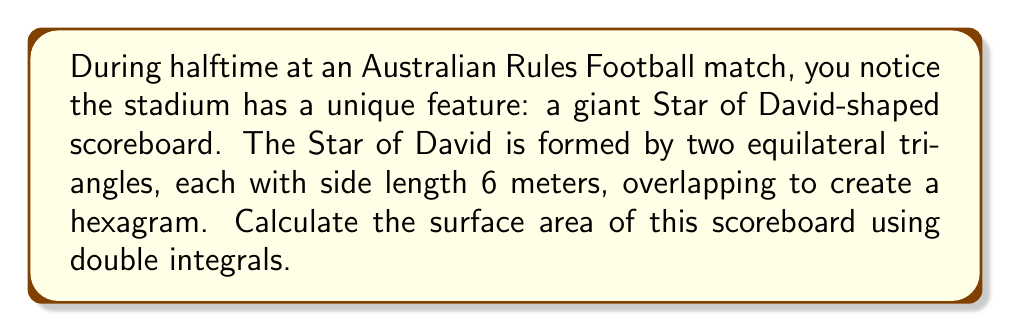Give your solution to this math problem. Let's approach this step-by-step:

1) First, we need to set up our coordinate system. Let's place the center of the Star of David at the origin (0,0) and align one of the triangles so that its base is parallel to the x-axis.

2) The Star of David can be divided into 12 congruent right triangles. We'll focus on one of these triangles in the first quadrant.

3) The equations of the lines forming this triangle are:
   $$y = \frac{\sqrt{3}}{3}x$$ (lower line)
   $$y = \sqrt{3}x$$ (upper line)

4) The x-coordinate where these lines intersect is at $x = \frac{3}{2}$.

5) We can now set up our double integral. We'll integrate with respect to y first, then x:

   $$A = 12 \int_0^{3/2} \int_{\frac{\sqrt{3}}{3}x}^{\sqrt{3}x} dy dx$$

6) Evaluating the inner integral:

   $$A = 12 \int_0^{3/2} [\sqrt{3}x - \frac{\sqrt{3}}{3}x] dx = 8\sqrt{3} \int_0^{3/2} x dx$$

7) Evaluating the outer integral:

   $$A = 8\sqrt{3} [\frac{1}{2}x^2]_0^{3/2} = 8\sqrt{3} \cdot \frac{1}{2} \cdot (\frac{9}{4}) = 9\sqrt{3}$$

8) Therefore, the surface area of the Star of David is $9\sqrt{3}$ square meters.
Answer: $9\sqrt{3}$ m² 